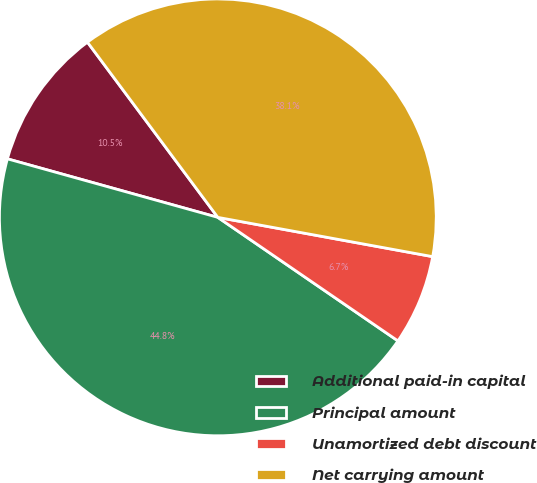Convert chart to OTSL. <chart><loc_0><loc_0><loc_500><loc_500><pie_chart><fcel>Additional paid-in capital<fcel>Principal amount<fcel>Unamortized debt discount<fcel>Net carrying amount<nl><fcel>10.5%<fcel>44.75%<fcel>6.69%<fcel>38.06%<nl></chart> 